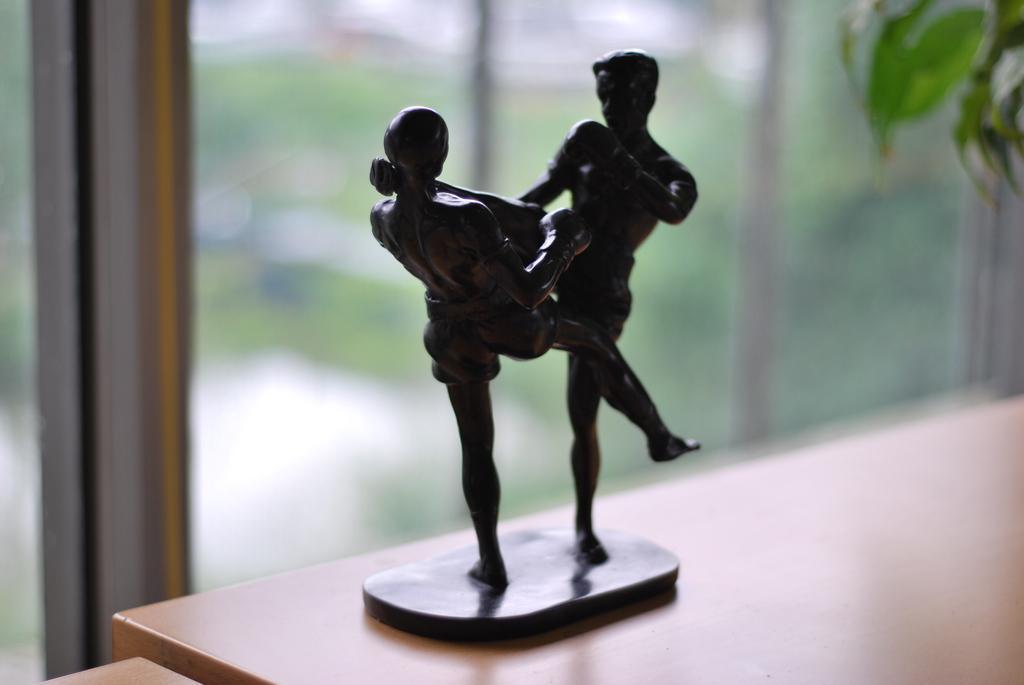Please provide a concise description of this image. In this image we can see a statue which resembles like a human and we can see two people and the statue is placed on a surface. The image in the background is blurred. 